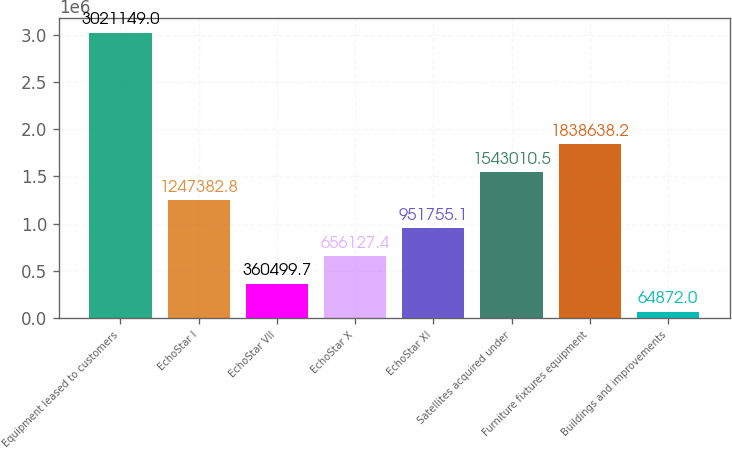Convert chart. <chart><loc_0><loc_0><loc_500><loc_500><bar_chart><fcel>Equipment leased to customers<fcel>EchoStar I<fcel>EchoStar VII<fcel>EchoStar X<fcel>EchoStar XI<fcel>Satellites acquired under<fcel>Furniture fixtures equipment<fcel>Buildings and improvements<nl><fcel>3.02115e+06<fcel>1.24738e+06<fcel>360500<fcel>656127<fcel>951755<fcel>1.54301e+06<fcel>1.83864e+06<fcel>64872<nl></chart> 